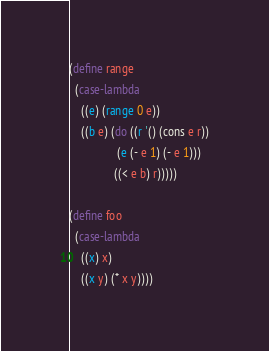<code> <loc_0><loc_0><loc_500><loc_500><_Scheme_>
(define range
  (case-lambda 
    ((e) (range 0 e))
    ((b e) (do ((r '() (cons e r))
                (e (- e 1) (- e 1)))
               ((< e b) r)))))

(define foo
  (case-lambda
    ((x) x)
    ((x y) (* x y))))
</code> 